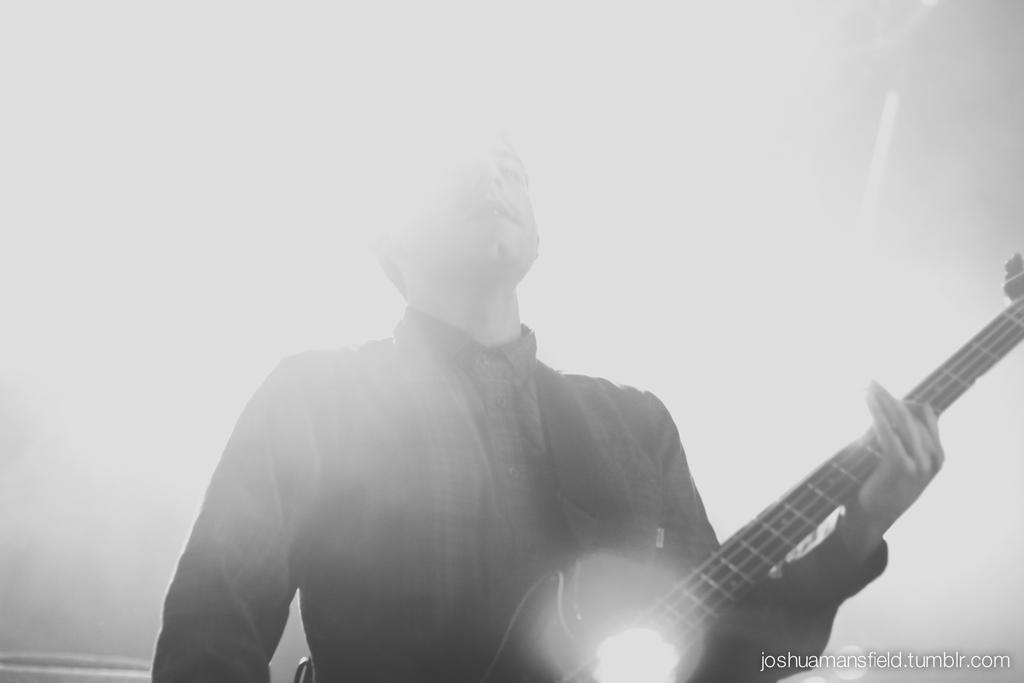Please provide a concise description of this image. A black and white picture. This man is standing and playing a guitar. 